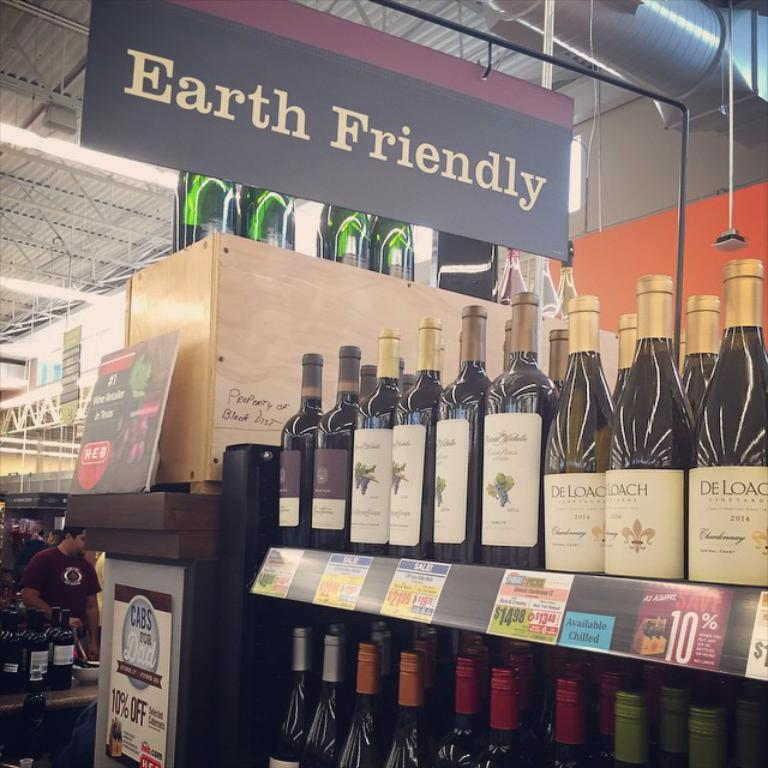<image>
Present a compact description of the photo's key features. A store selling wine has a sign from the ceiling says, Earth Friendly." 